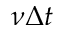<formula> <loc_0><loc_0><loc_500><loc_500>\nu \Delta t</formula> 